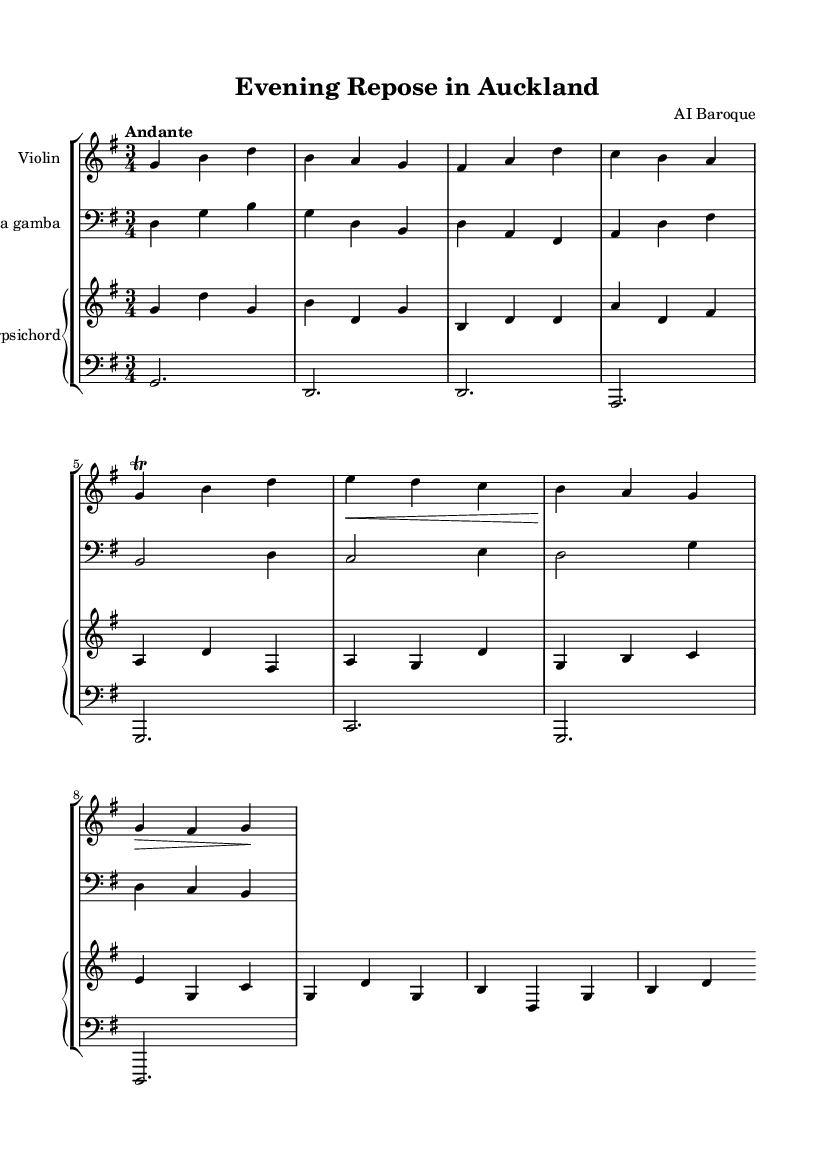What is the key signature of this music? The key signature is determined by looking at the key signature indicator at the beginning of the staff. It shows one sharp, which corresponds to G major.
Answer: G major What is the time signature of this music? The time signature is found at the beginning of the score and indicates the number of beats in each measure. Here, it shows 3/4, meaning there are three quarter-note beats per measure.
Answer: 3/4 What is the indicated tempo for this piece? The tempo marking is written above the staff and indicates how fast the piece should be played. In this case, it reads "Andante," which is a moderate tempo.
Answer: Andante How many instruments are there in this score? By counting the lines and staves, we can identify how many instruments are present. There are three staves: one for the violin, one for the viola da gamba, and a piano staff that contains both right and left hands. Therefore, there are four parts for three instruments.
Answer: Three Which instrument is using the bass clef? The use of the bass clef represents the lower range of pitches. In this score, the viola da gamba is written in the bass clef, distinguishing it as an instrument that handles lower notes.
Answer: Viola da gamba What type of ornamentation is used in the violin part? Ornamentations are often noted in the music as specific symbols. The violin part features a trill, indicated by the notation "tr," suggesting the musician should perform this ornamentation by rapidly alternating between two adjacent notes.
Answer: Trill What does the "piano" marking in the harpsichord indicate? The term "piano" refers to a dynamic marking and instructs the performer to play softly. This detail is important for conveying the overall feeling of the music at that moment.
Answer: Softly 